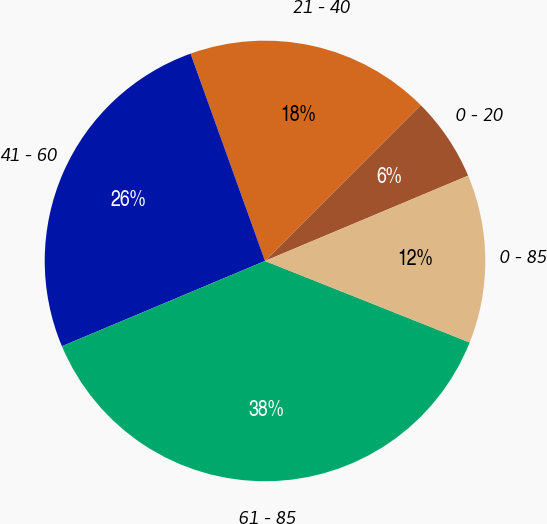<chart> <loc_0><loc_0><loc_500><loc_500><pie_chart><fcel>0 - 20<fcel>21 - 40<fcel>41 - 60<fcel>61 - 85<fcel>0 - 85<nl><fcel>6.18%<fcel>17.98%<fcel>25.84%<fcel>37.64%<fcel>12.36%<nl></chart> 